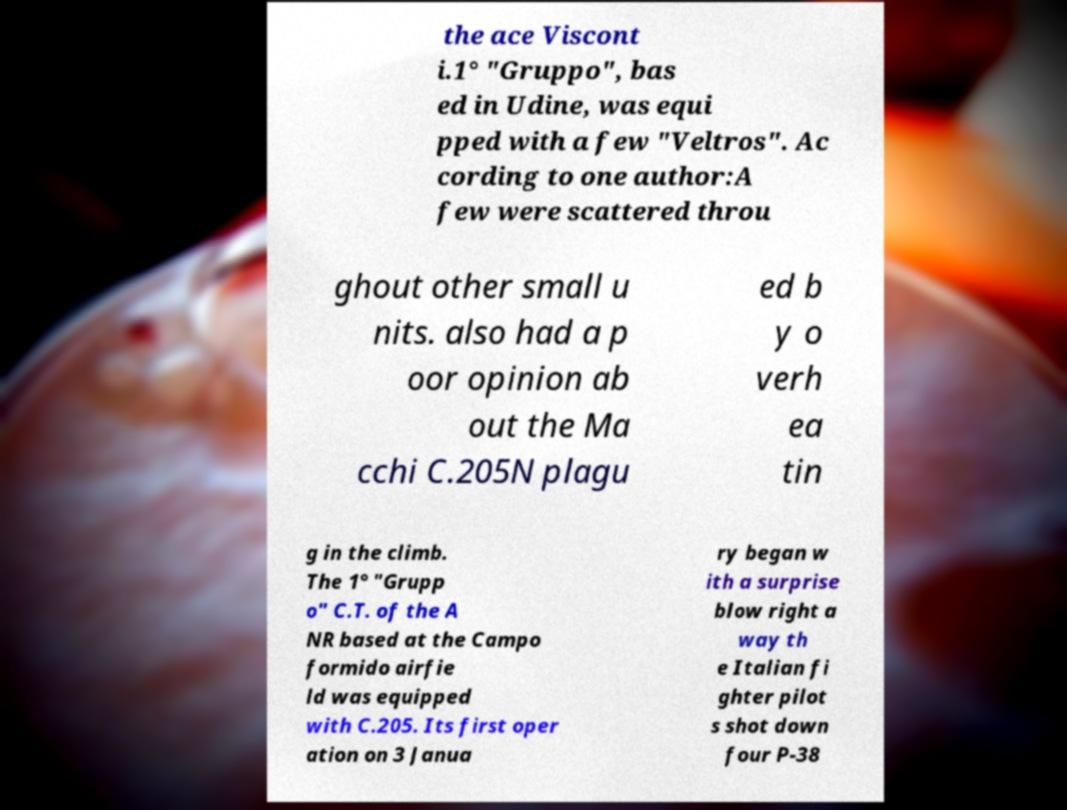Could you extract and type out the text from this image? the ace Viscont i.1° "Gruppo", bas ed in Udine, was equi pped with a few "Veltros". Ac cording to one author:A few were scattered throu ghout other small u nits. also had a p oor opinion ab out the Ma cchi C.205N plagu ed b y o verh ea tin g in the climb. The 1° "Grupp o" C.T. of the A NR based at the Campo formido airfie ld was equipped with C.205. Its first oper ation on 3 Janua ry began w ith a surprise blow right a way th e Italian fi ghter pilot s shot down four P-38 